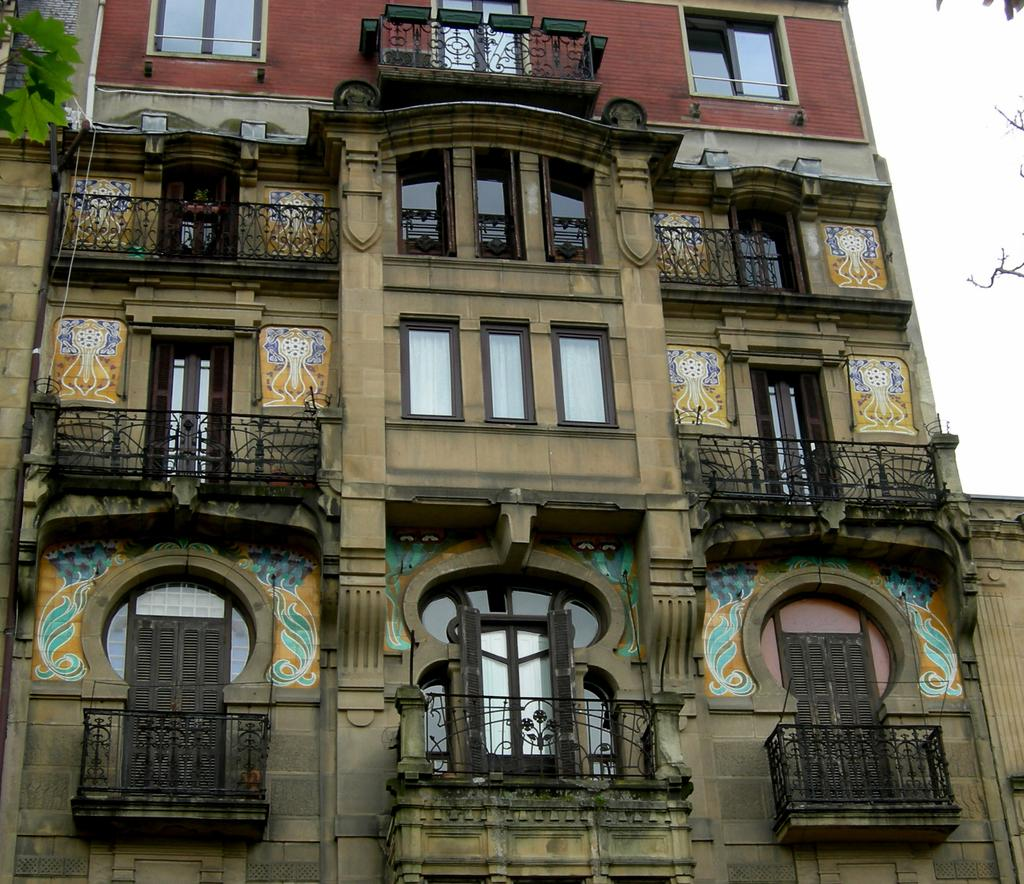What type of structure is present in the image? There is a building in the image. What features can be seen on the building? The building has windows and doors. What can be seen on the right side of the image? The sky is visible on the right side of the image. What color is the silver sock that someone is wearing in the image? There is no silver sock or person wearing a sock in the image. 